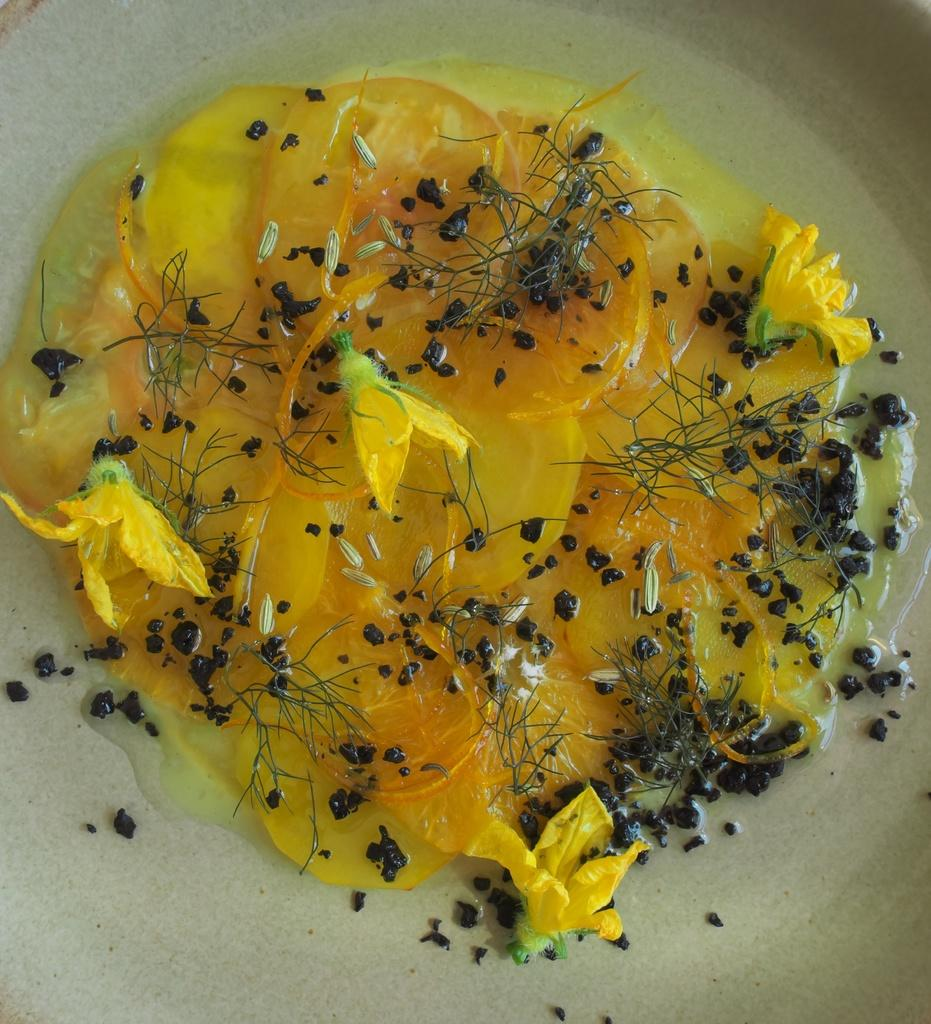What object can be seen in the image that might be used for serving or presenting food? There is a plate in the image that can be used for serving or presenting food. What is on the plate in the image? There is food on the plate in the image. How many bikes are parked next to the plate in the image? There are no bikes present in the image; it only features a plate with food on it. 